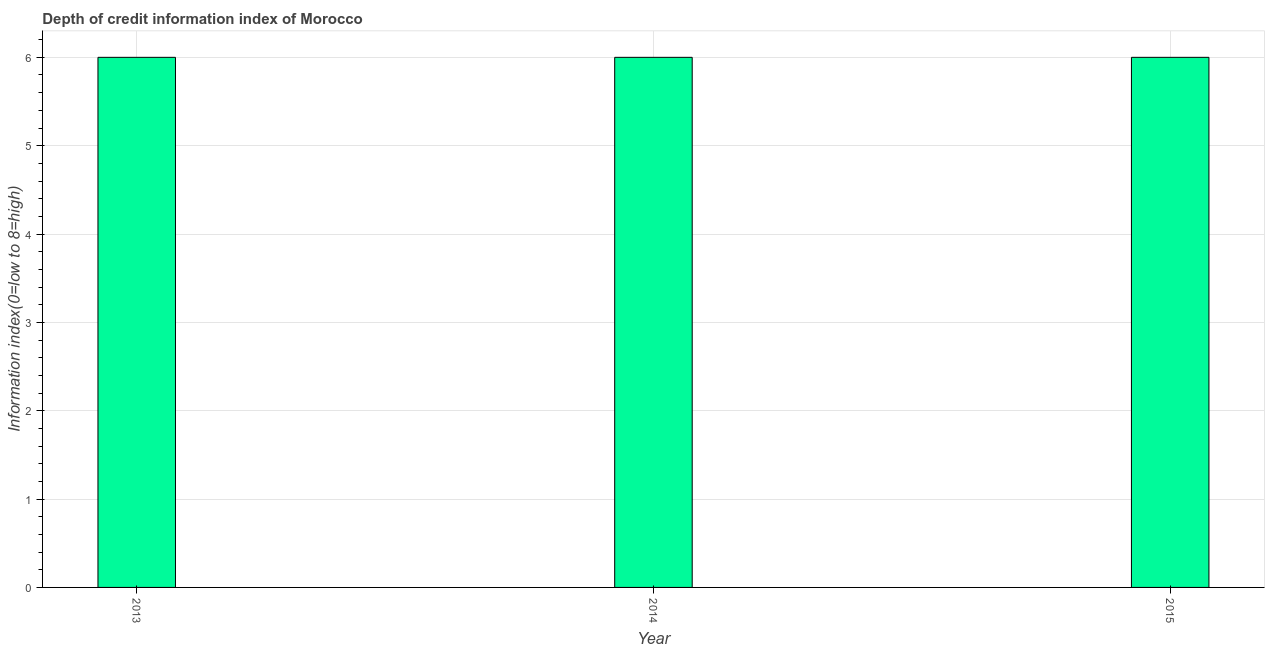Does the graph contain any zero values?
Offer a very short reply. No. Does the graph contain grids?
Your answer should be compact. Yes. What is the title of the graph?
Keep it short and to the point. Depth of credit information index of Morocco. What is the label or title of the Y-axis?
Your answer should be compact. Information index(0=low to 8=high). What is the sum of the depth of credit information index?
Offer a very short reply. 18. What is the difference between the depth of credit information index in 2014 and 2015?
Provide a succinct answer. 0. What is the average depth of credit information index per year?
Make the answer very short. 6. Do a majority of the years between 2015 and 2013 (inclusive) have depth of credit information index greater than 3.2 ?
Your answer should be compact. Yes. Is the depth of credit information index in 2014 less than that in 2015?
Keep it short and to the point. No. What is the difference between the highest and the second highest depth of credit information index?
Offer a very short reply. 0. How many bars are there?
Your answer should be compact. 3. Are all the bars in the graph horizontal?
Give a very brief answer. No. How many years are there in the graph?
Provide a succinct answer. 3. What is the difference between two consecutive major ticks on the Y-axis?
Provide a succinct answer. 1. What is the Information index(0=low to 8=high) in 2014?
Provide a short and direct response. 6. What is the Information index(0=low to 8=high) of 2015?
Your answer should be compact. 6. What is the difference between the Information index(0=low to 8=high) in 2013 and 2015?
Make the answer very short. 0. What is the difference between the Information index(0=low to 8=high) in 2014 and 2015?
Provide a succinct answer. 0. What is the ratio of the Information index(0=low to 8=high) in 2013 to that in 2014?
Your answer should be compact. 1. What is the ratio of the Information index(0=low to 8=high) in 2013 to that in 2015?
Make the answer very short. 1. 